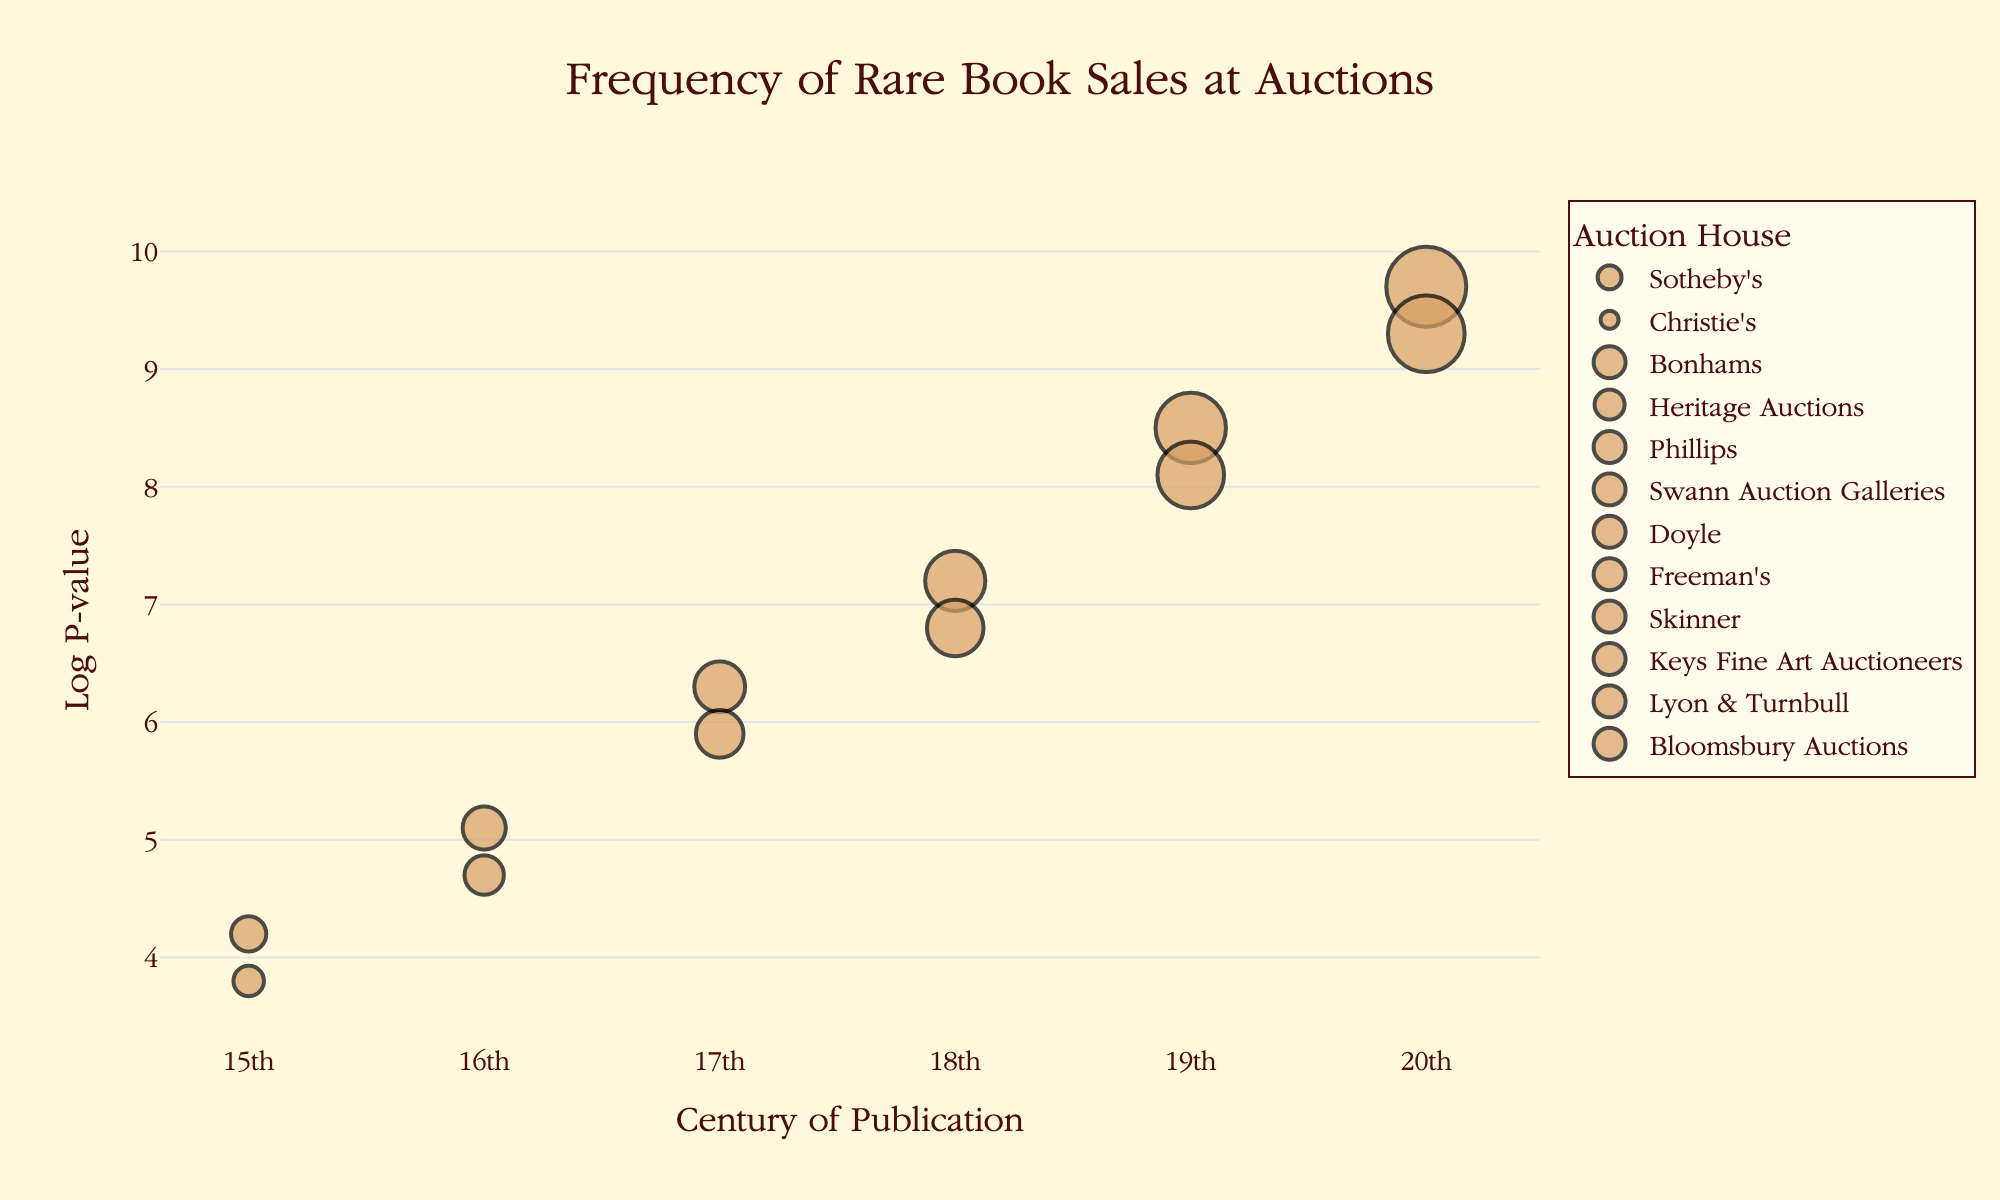Which auction house has the highest Log P-value? Find the point representing the highest Log P-value on the y-axis and see which auction house it corresponds to. The highest Log P-value is 9.7, corresponding to Lyon & Turnbull.
Answer: Lyon & Turnbull Which century has the most frequent rare book sales at auctions? Determine which century has the largest bubble size, as larger bubbles represent higher frequencies. The largest bubbles are found in the 20th century.
Answer: 20th century How many sales does Skinner have for 19th-century publications? Locate the point for Skinner in the 19th century and refer to the hover text, which indicates the frequency of sales. It states '48 sales' in the hover text.
Answer: 48 What's the Log P-value for Christie's in the 15th century? Identify the point for Christie's in the 15th century and refer to its y-coordinate for the Log P-value. The Log P-value is 3.8 for Christie's in the 15th century.
Answer: 3.8 Which century shows the lowest Log P-value and which auction house is it associated with? Find the point with the lowest Log P-value on the y-axis and refer to its associated auction house. The lowest Log P-value is 3.8, associated with Christie's in the 15th century.
Answer: 15th century, Christie's Compare the frequency of sales between Sotheby's in the 15th century and Bonhams in the 16th century. Locate the points for Sotheby's in the 15th century and Bonhams in the 16th century and compare their bubble sizes and hover texts. Sotheby’s has 12 sales, and Bonhams has 18 sales.
Answer: Bonhams has a higher frequency with 18 sales What is the difference in Log P-value between Freeman's in the 18th century and Phillips in the 17th century? Find the points for Freeman's in the 18th century and Phillips in the 17th century, read their Log P-values, and subtract them. Freeman's has a Log P-value of 6.8, and Phillips has 6.3, so the difference is 0.5.
Answer: 0.5 Which century has the highest concentration of auction houses based on the plot? Observe the distribution of points along the x-axis (centuries) and determine where the most auction houses are clustered. The 20th century shows the highest concentration with the most points.
Answer: 20th century What is the average Log P-value for the auction houses in the 17th century? Locate all points in the 17th century and average their Log P-values. The Log P-values are 6.3 for Phillips and 5.9 for Swann Auction Galleries, averaging (6.3 + 5.9) / 2 = 6.1.
Answer: 6.1 